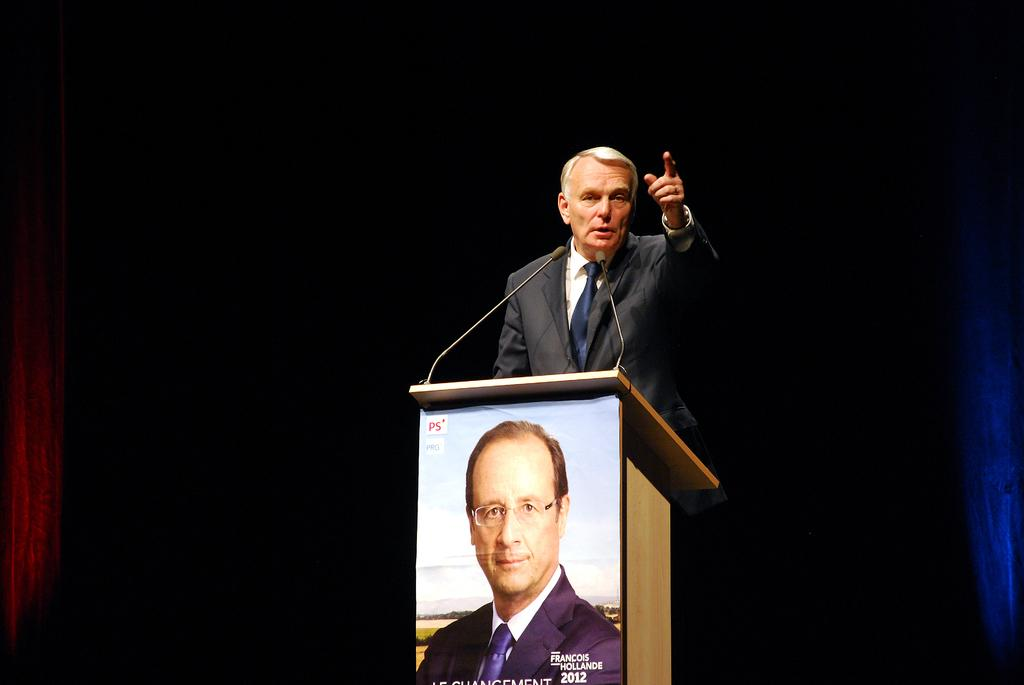What is the man in the image doing? The man is standing in the image. What is the man wearing in the image? The man is wearing formal dress in the image. What object can be seen in the image that is often used for speeches or presentations? There is a podium in the image. What objects are present in the image that are used for amplifying sound? There are microphones in the image. What can be seen on the poster in the image? There is a poster of a man in the image. What type of apparatus is being used to grow the seed in the image? There is no apparatus or seed present in the image. What nation is represented by the man on the poster in the image? The image does not provide enough information to determine the nationality of the man on the poster. 